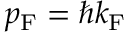<formula> <loc_0><loc_0><loc_500><loc_500>p _ { F } = \hbar { k } _ { F }</formula> 